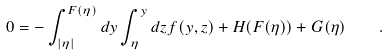Convert formula to latex. <formula><loc_0><loc_0><loc_500><loc_500>0 = - \int ^ { F ( \eta ) } _ { | \eta | } d y \int ^ { y } _ { \eta } d z f ( y , z ) + H ( F ( \eta ) ) + G ( \eta ) \quad .</formula> 